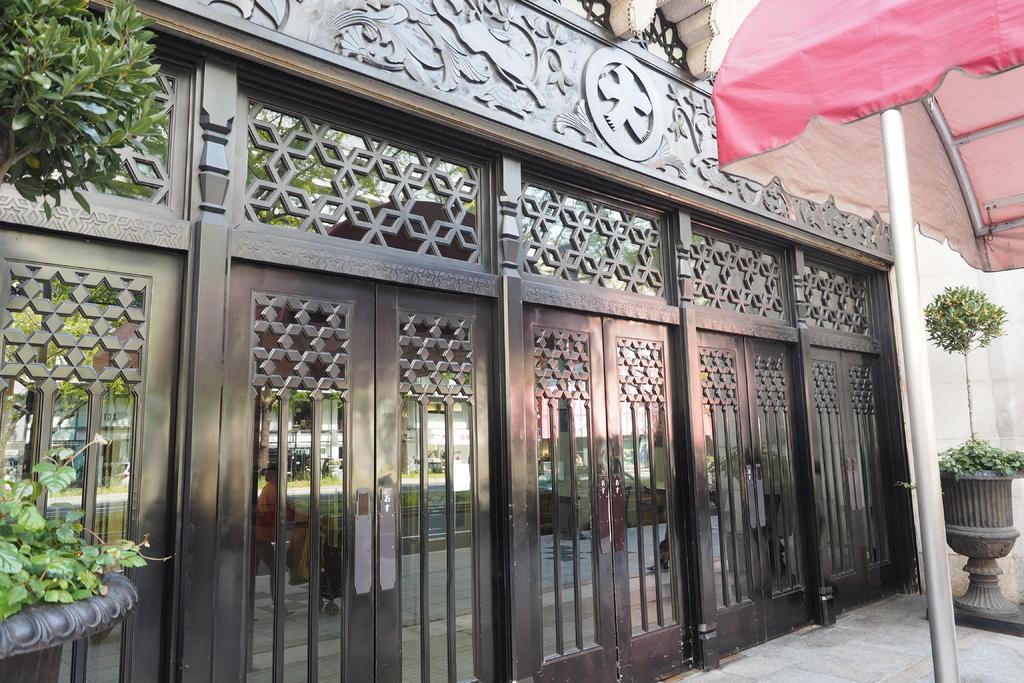Please provide a concise description of this image. In this picture I see the doors in front and I see the plants on both the sides and on the right side of this picture I see a pole on which there is a cloth and I see few rods. 